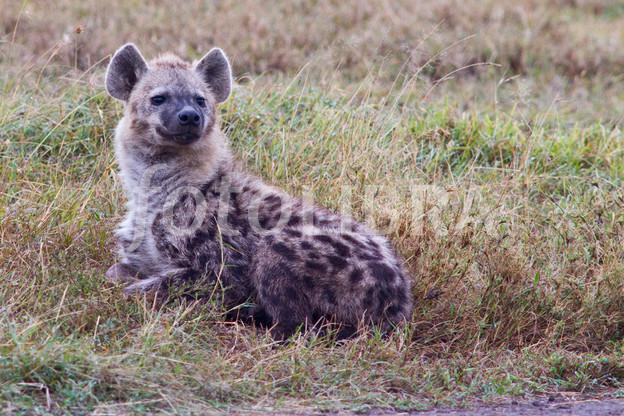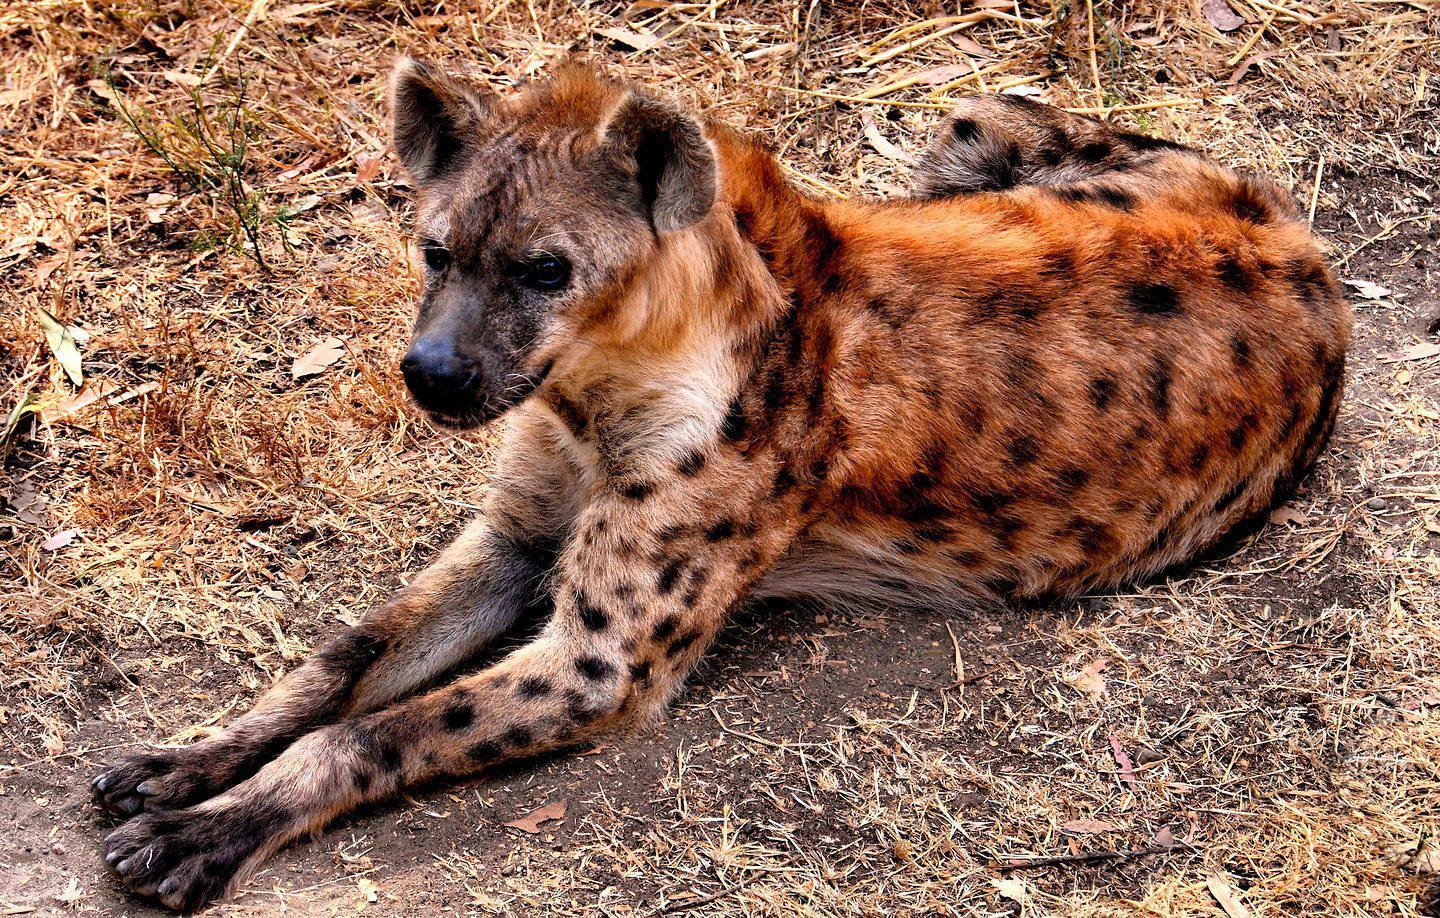The first image is the image on the left, the second image is the image on the right. Considering the images on both sides, is "Each image features one hyena with distinctive spotted fur, and the hyena on the left has its head turned around, while the hyena on the right reclines with its front paws extended." valid? Answer yes or no. Yes. The first image is the image on the left, the second image is the image on the right. Considering the images on both sides, is "There is a single adult hyena in each image, but they are looking in opposite directions." valid? Answer yes or no. Yes. 